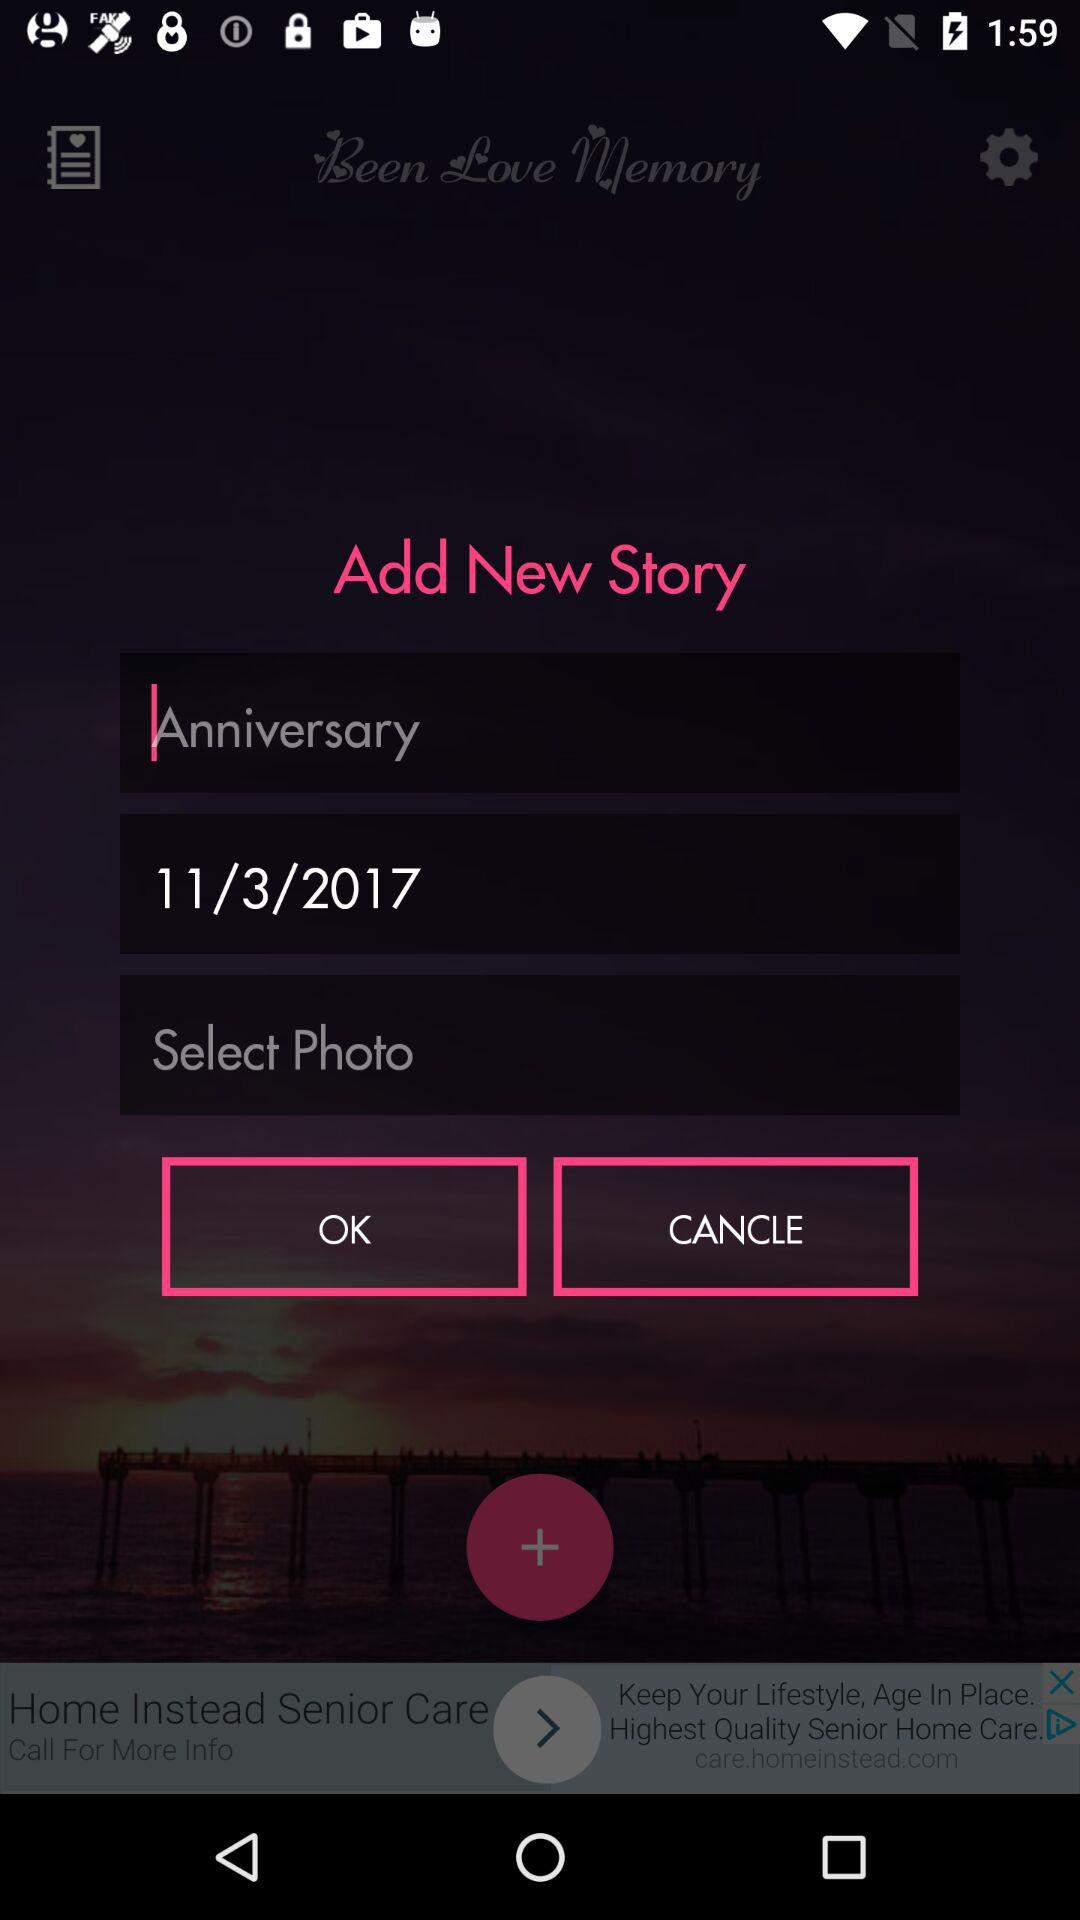What date is shown? The shown date is March 11, 2017. 